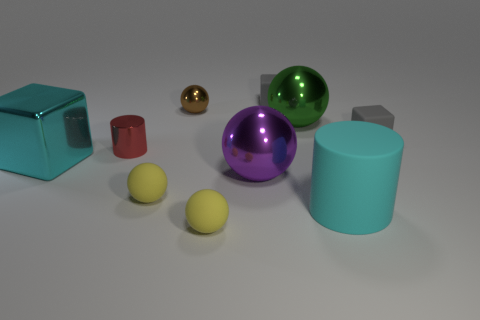Are there fewer small brown metallic objects that are in front of the green shiny thing than large blue rubber balls?
Your answer should be very brief. No. What is the size of the matte cylinder that is the same color as the metallic cube?
Give a very brief answer. Large. Are there any other things that are the same size as the matte cylinder?
Provide a succinct answer. Yes. Does the green ball have the same material as the purple object?
Your answer should be compact. Yes. What number of objects are cyan objects in front of the cyan block or gray things right of the big rubber thing?
Provide a succinct answer. 2. Are there any matte objects of the same size as the brown shiny object?
Keep it short and to the point. Yes. There is another large thing that is the same shape as the big purple metal object; what is its color?
Your answer should be very brief. Green. There is a gray rubber object that is in front of the tiny brown metal object; is there a metal sphere that is to the right of it?
Give a very brief answer. No. Do the metallic thing on the left side of the red object and the tiny red object have the same shape?
Provide a short and direct response. No. What shape is the big rubber object?
Your response must be concise. Cylinder. 